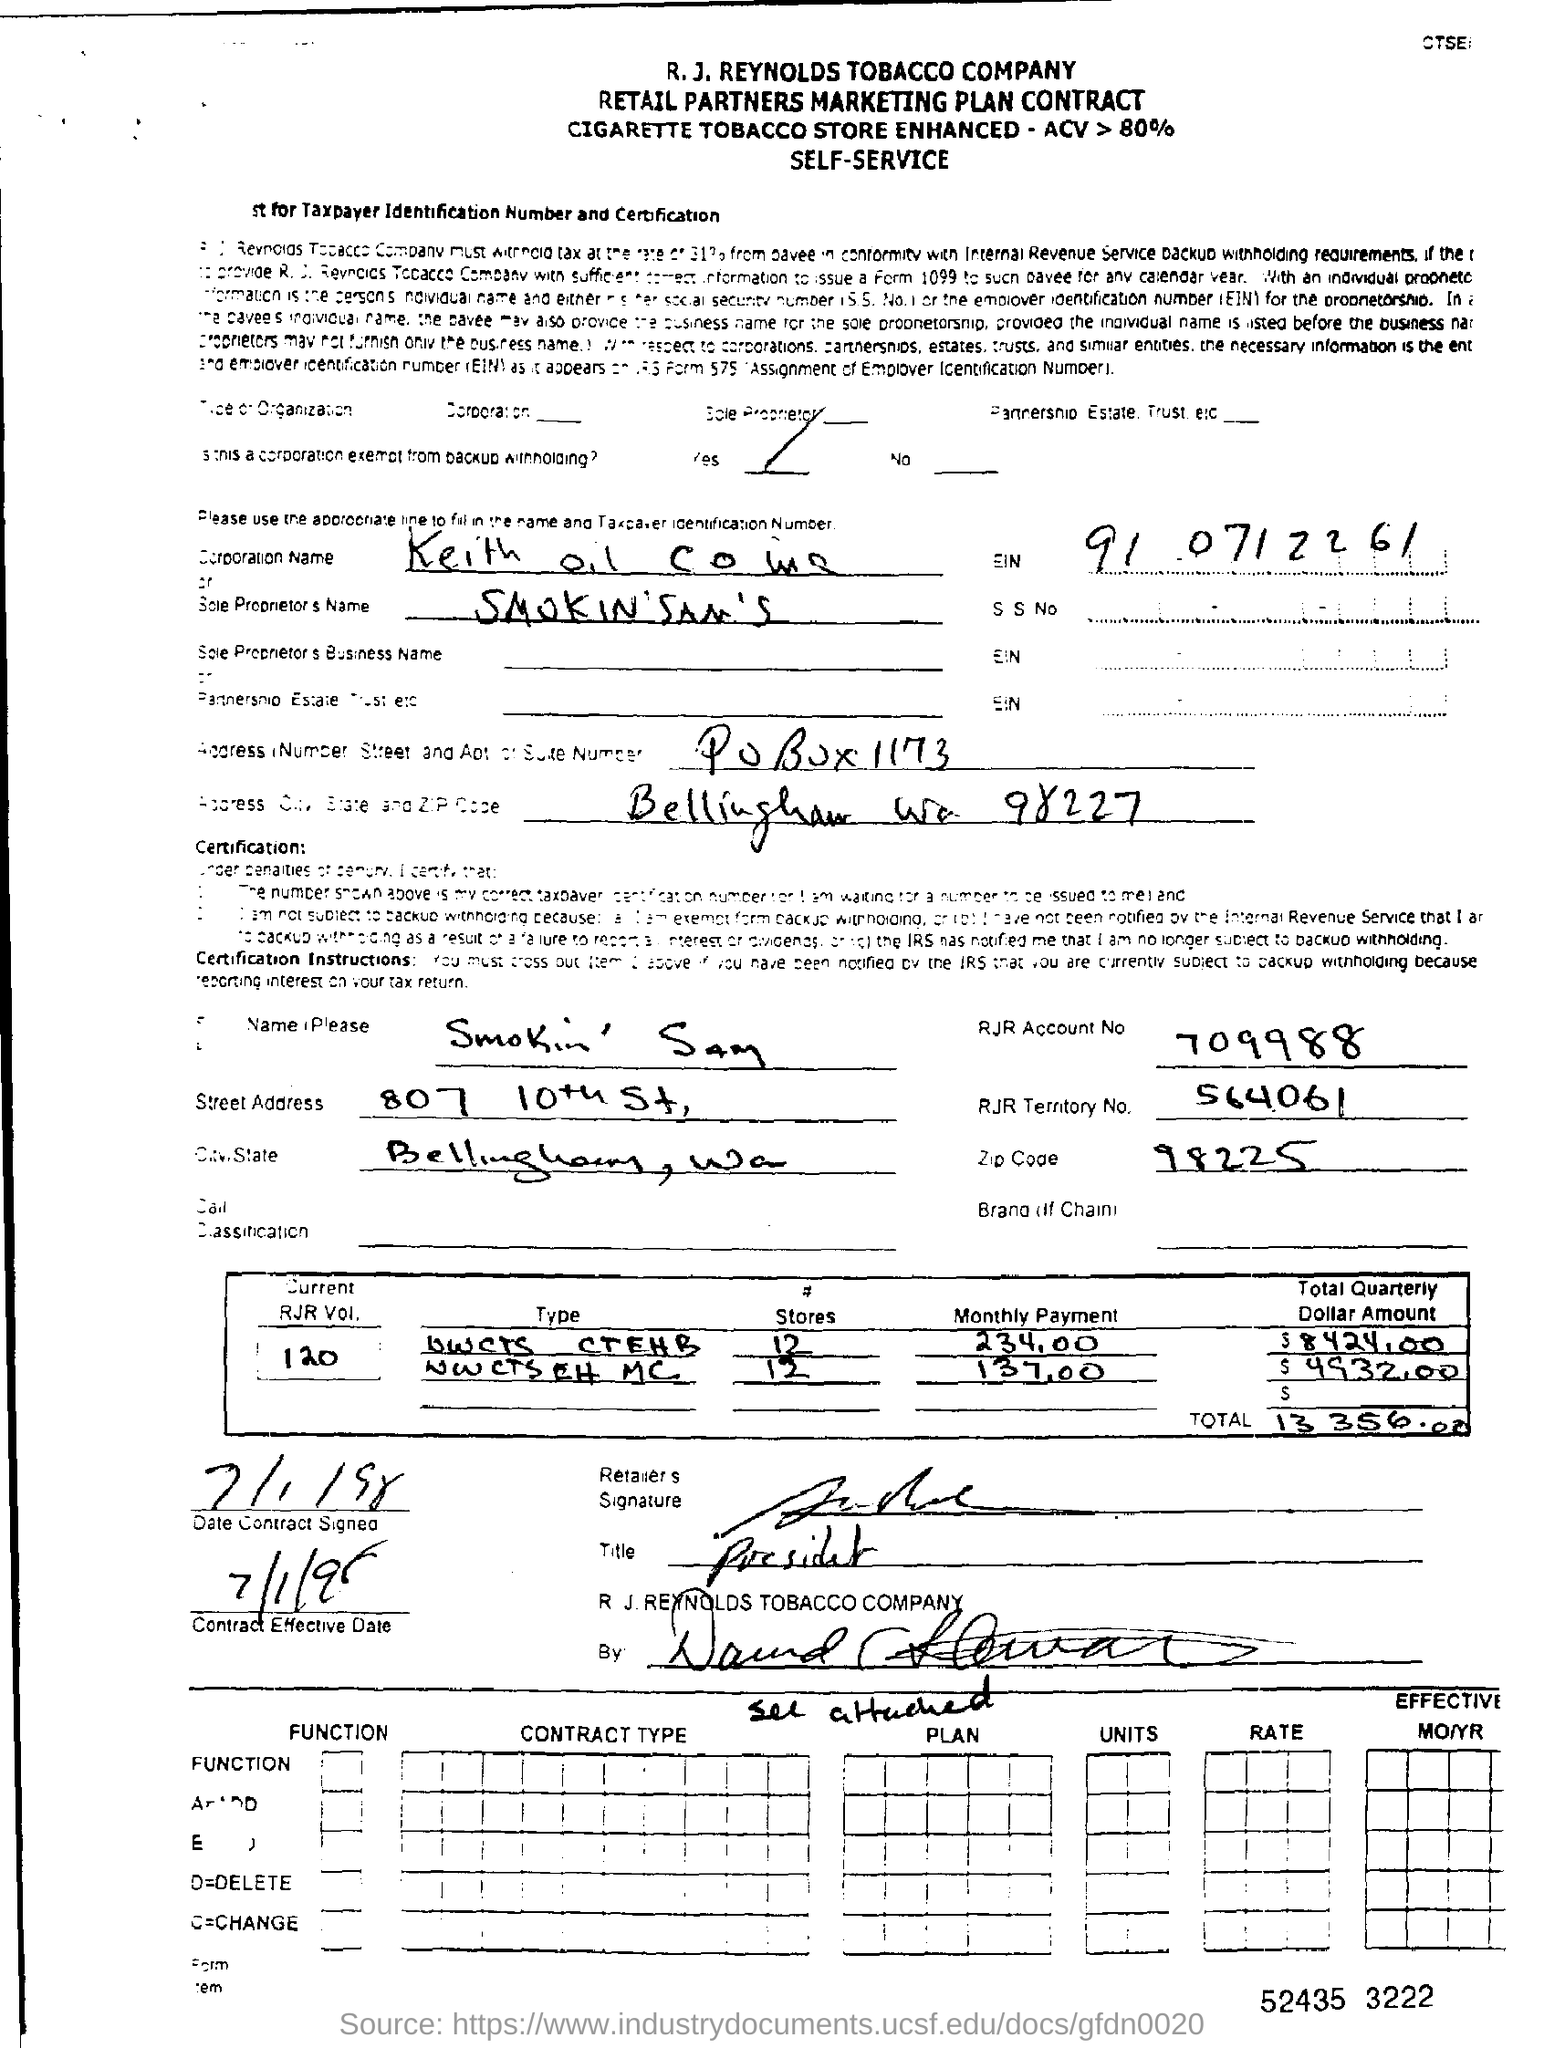Highlight a few significant elements in this photo. The RJR Account Number mentioned in the contract form is 709988. The RJR territory number mentioned in the contract is 564061. This is a retail partners marketing plan contract. The date of contract signed was July 1, 1998. The current RJR volume number mentioned in the contract is 120. 